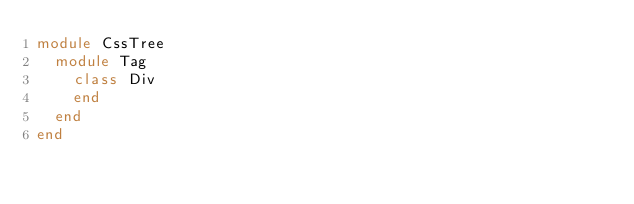<code> <loc_0><loc_0><loc_500><loc_500><_Ruby_>module CssTree
  module Tag
    class Div
    end
  end
end
</code> 